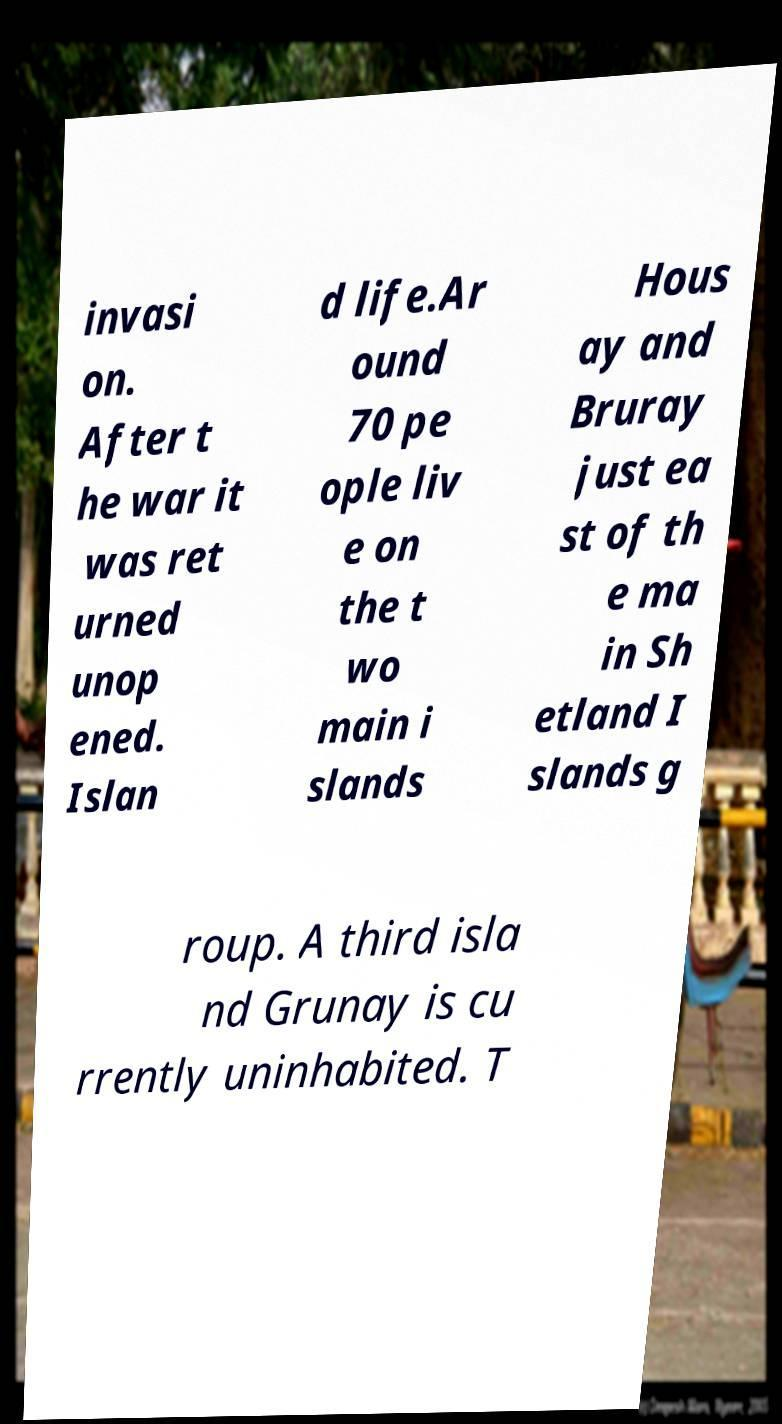Could you extract and type out the text from this image? invasi on. After t he war it was ret urned unop ened. Islan d life.Ar ound 70 pe ople liv e on the t wo main i slands Hous ay and Bruray just ea st of th e ma in Sh etland I slands g roup. A third isla nd Grunay is cu rrently uninhabited. T 